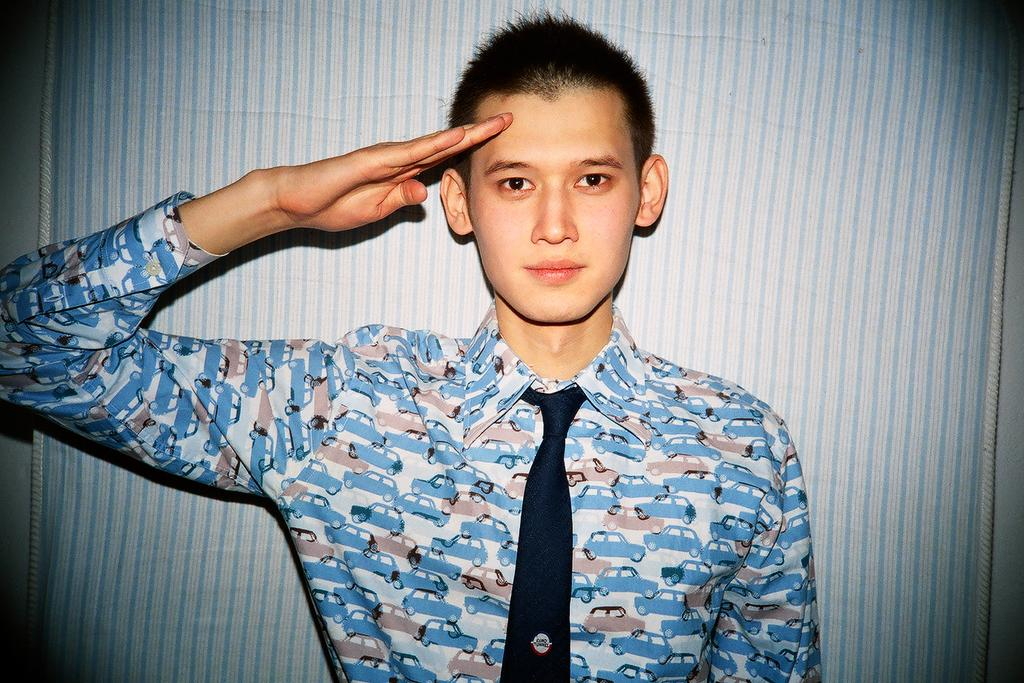What is present in the image? There is a person in the image. Can you describe the person's attire? The person is wearing a dress with blue, white, and pink colors, and a tie. What can be seen in the background of the image? There is a blue and white cloth on the wall in the background of the image. What type of rhythm is the person dancing to in the image? There is no indication of dancing or rhythm in the image; the person is simply standing or posing. Can you tell me what book the person is holding in the image? There is no book present in the image. What flavor of eggnog is the person drinking in the image? There is no eggnog or any beverage present in the image. 